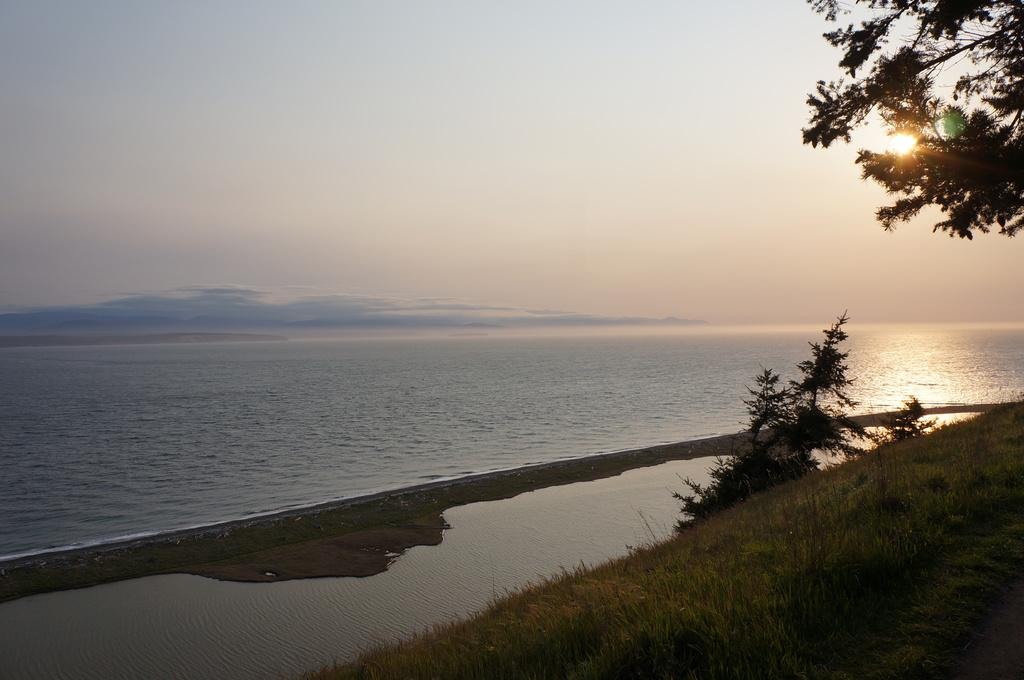What is located in the middle of the image? There is water in the middle of the image. What type of vegetation is on the right side of the image? There are trees on the right side of the image. What celestial body is visible on the right side of the image? The sun is visible on the right side of the image. What is visible at the top of the image? The sky is visible at the top of the image. What news is being reported by the fish in the image? There are no fish present in the image, and therefore no news can be reported by them. What feeling is the sky expressing in the image? The sky is not capable of expressing feelings, as it is a natural phenomenon. 